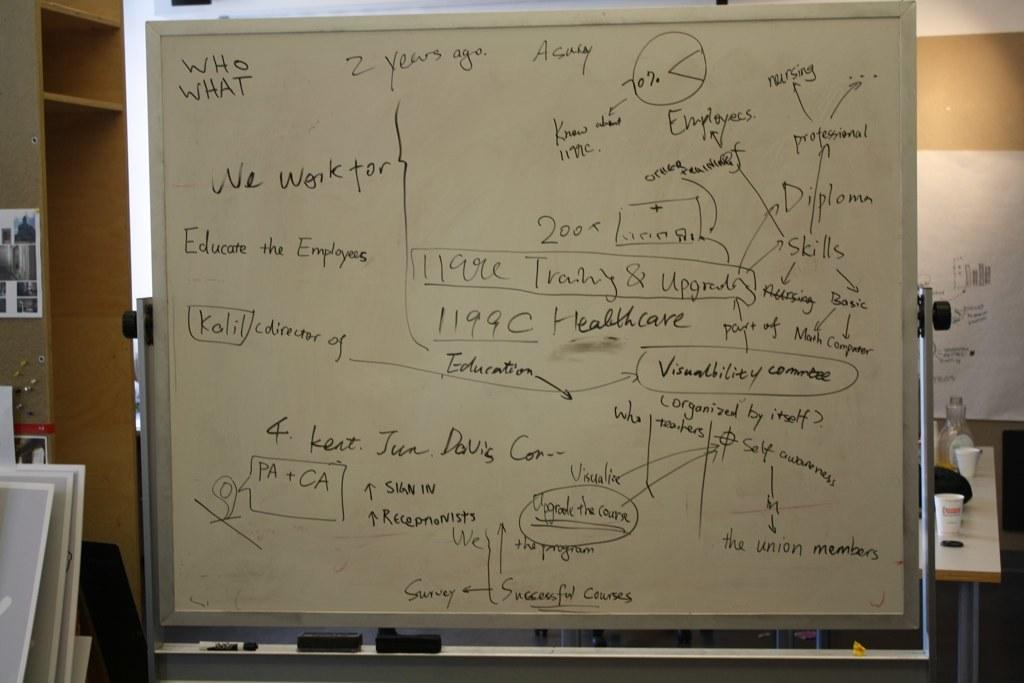<image>
Summarize the visual content of the image. A white board diagram relating to how to educate the employees. 